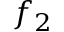<formula> <loc_0><loc_0><loc_500><loc_500>f _ { 2 }</formula> 